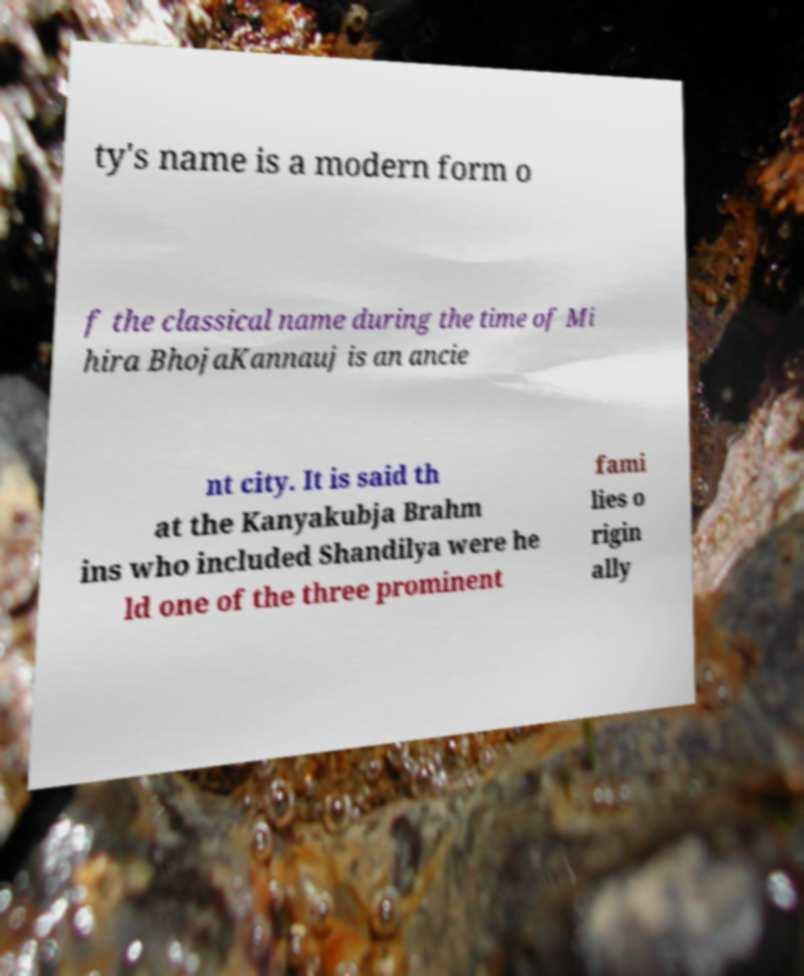I need the written content from this picture converted into text. Can you do that? ty's name is a modern form o f the classical name during the time of Mi hira BhojaKannauj is an ancie nt city. It is said th at the Kanyakubja Brahm ins who included Shandilya were he ld one of the three prominent fami lies o rigin ally 